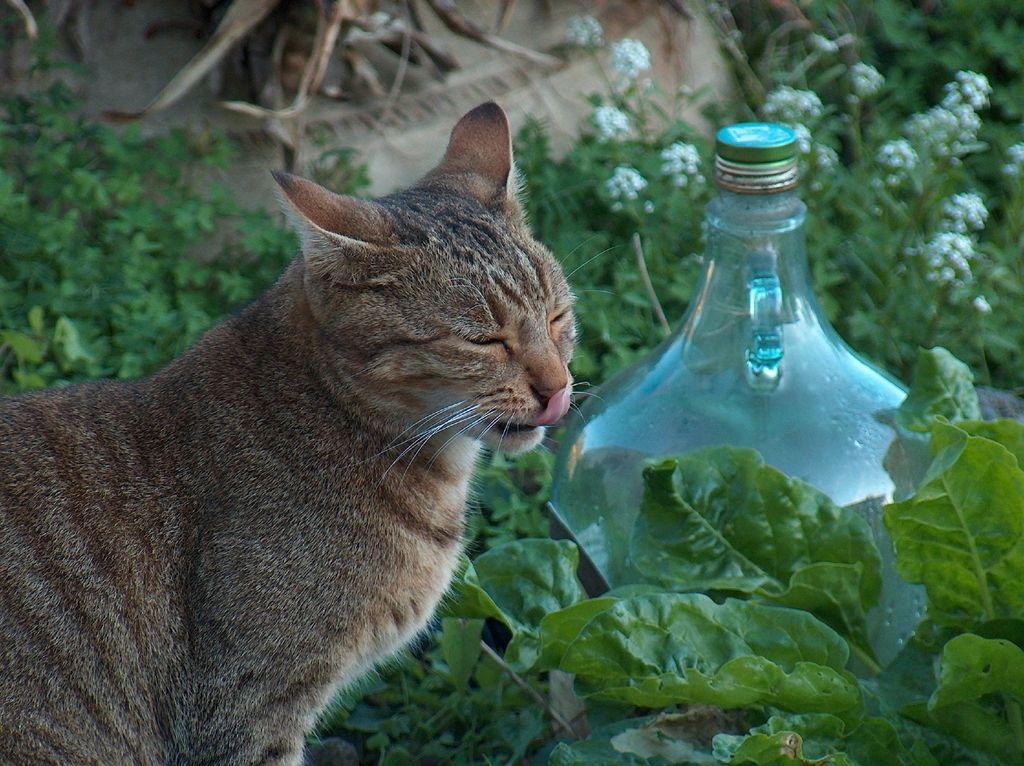What type of animal is in the image? There is a cat in the image. What is the cat doing in the image? The cat has its eyes closed. What other object can be seen in the image? There is a glass bottle in the image. What else is present in the image besides the cat and the bottle? There are plants in the image. What type of stage is visible in the image? There is no stage present in the image. What kind of bait is the cat using to catch fish in the image? There is no fishing or bait in the image; it features a cat with its eyes closed, a glass bottle, and plants. 